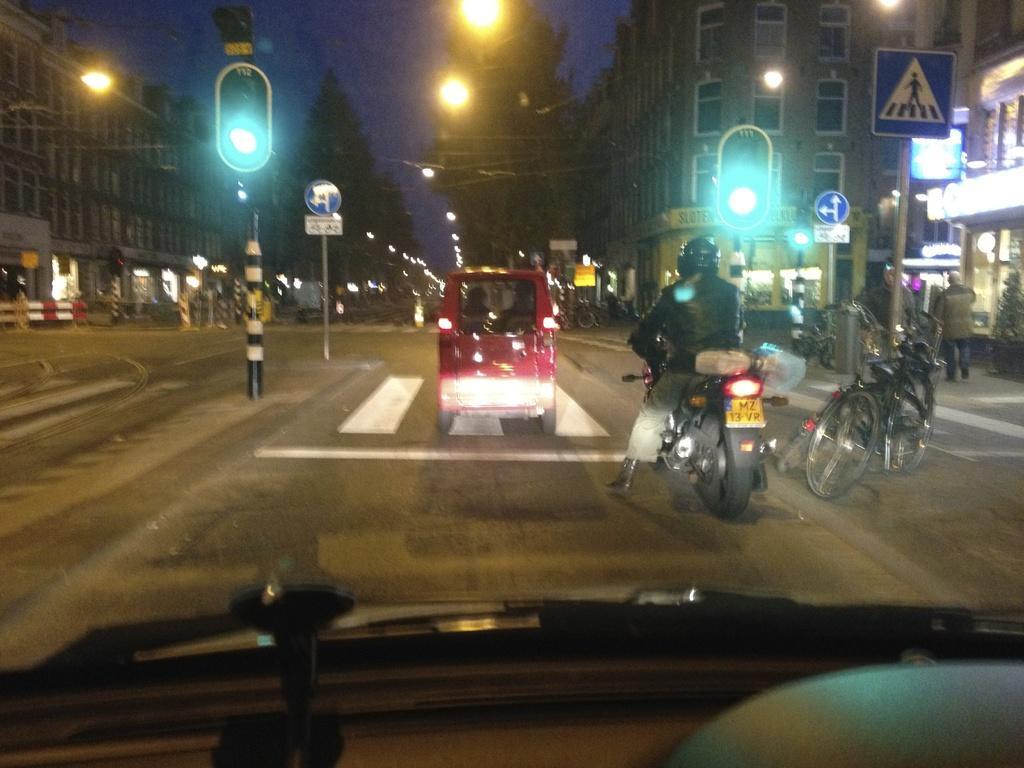Please provide a concise description of this image. In this image there are vehicles on the road. Left side a traffic light is attached to the pole. Behind there are boards attached to the pole. Right side there are boards attached to the poles. There traffic lights at the poles. Left side there is a fence. There are lights attached to the wires. Background there are buildings. Top of the image there is sky. Bottom of the image there is a vehicle. There is a person sitting on the bike. He is wearing a helmet. There are bicycles on the pavement. 